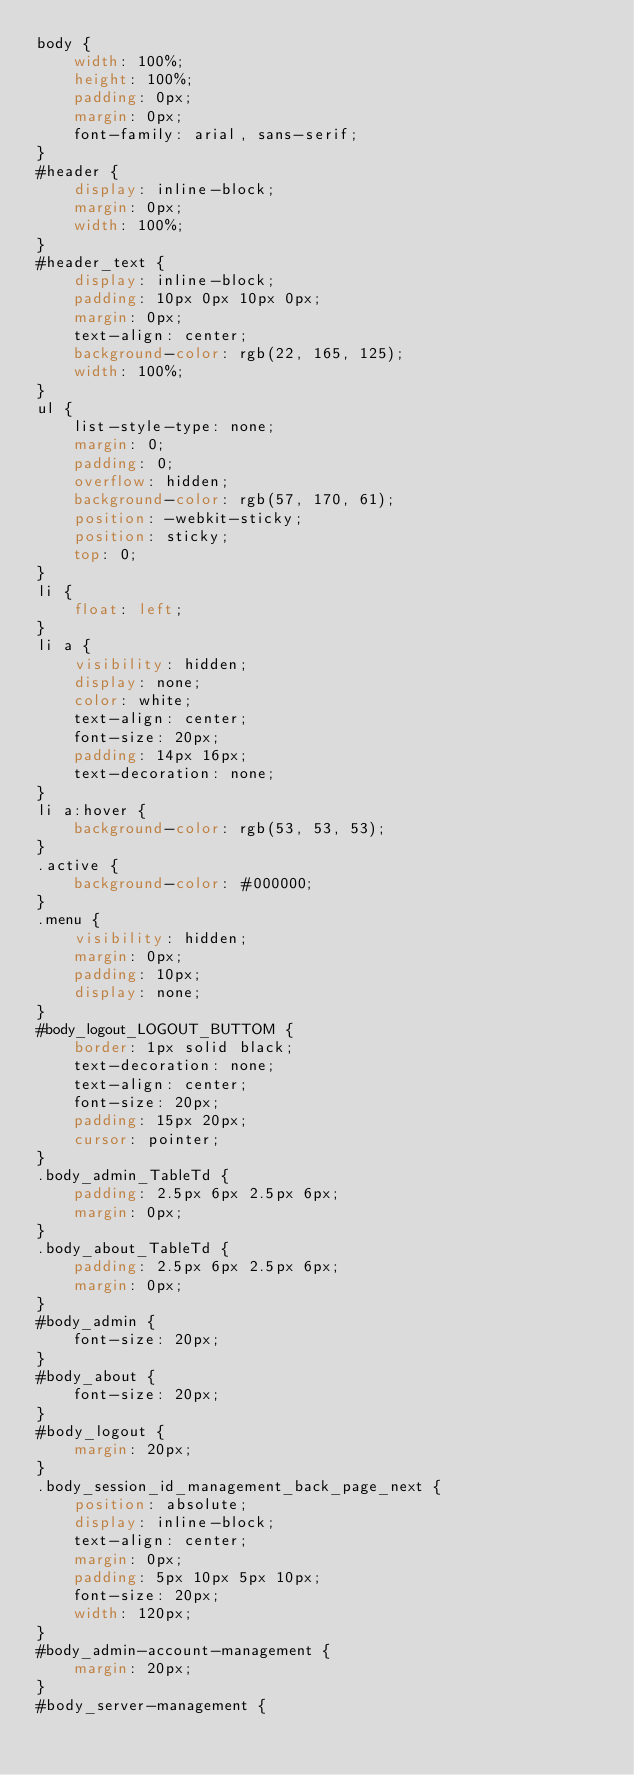<code> <loc_0><loc_0><loc_500><loc_500><_CSS_>body {
    width: 100%;
    height: 100%;
    padding: 0px;
    margin: 0px;
    font-family: arial, sans-serif;
}
#header {
    display: inline-block;
    margin: 0px;
    width: 100%;
}
#header_text {
    display: inline-block;
    padding: 10px 0px 10px 0px;
    margin: 0px;
    text-align: center;
    background-color: rgb(22, 165, 125);
    width: 100%;
}
ul {
    list-style-type: none;
    margin: 0;
    padding: 0;
    overflow: hidden;
    background-color: rgb(57, 170, 61);
    position: -webkit-sticky;
    position: sticky;
    top: 0;
}
li {
    float: left;
}
li a {
    visibility: hidden;
    display: none;
    color: white;
    text-align: center;
    font-size: 20px;
    padding: 14px 16px;
    text-decoration: none;
}
li a:hover {
    background-color: rgb(53, 53, 53);
}
.active {
    background-color: #000000;
}
.menu {
    visibility: hidden;
    margin: 0px;
    padding: 10px;
    display: none;
}
#body_logout_LOGOUT_BUTTOM {
    border: 1px solid black;
    text-decoration: none;
    text-align: center;
    font-size: 20px;
    padding: 15px 20px;
    cursor: pointer;
}
.body_admin_TableTd {
    padding: 2.5px 6px 2.5px 6px;
    margin: 0px;
}
.body_about_TableTd {
    padding: 2.5px 6px 2.5px 6px;
    margin: 0px;
}
#body_admin {
    font-size: 20px;
}
#body_about {
    font-size: 20px;
}
#body_logout {
    margin: 20px;
}
.body_session_id_management_back_page_next {
    position: absolute;
    display: inline-block;
    text-align: center;
    margin: 0px;
    padding: 5px 10px 5px 10px;
    font-size: 20px;
    width: 120px;
}
#body_admin-account-management {
    margin: 20px;
}
#body_server-management {</code> 